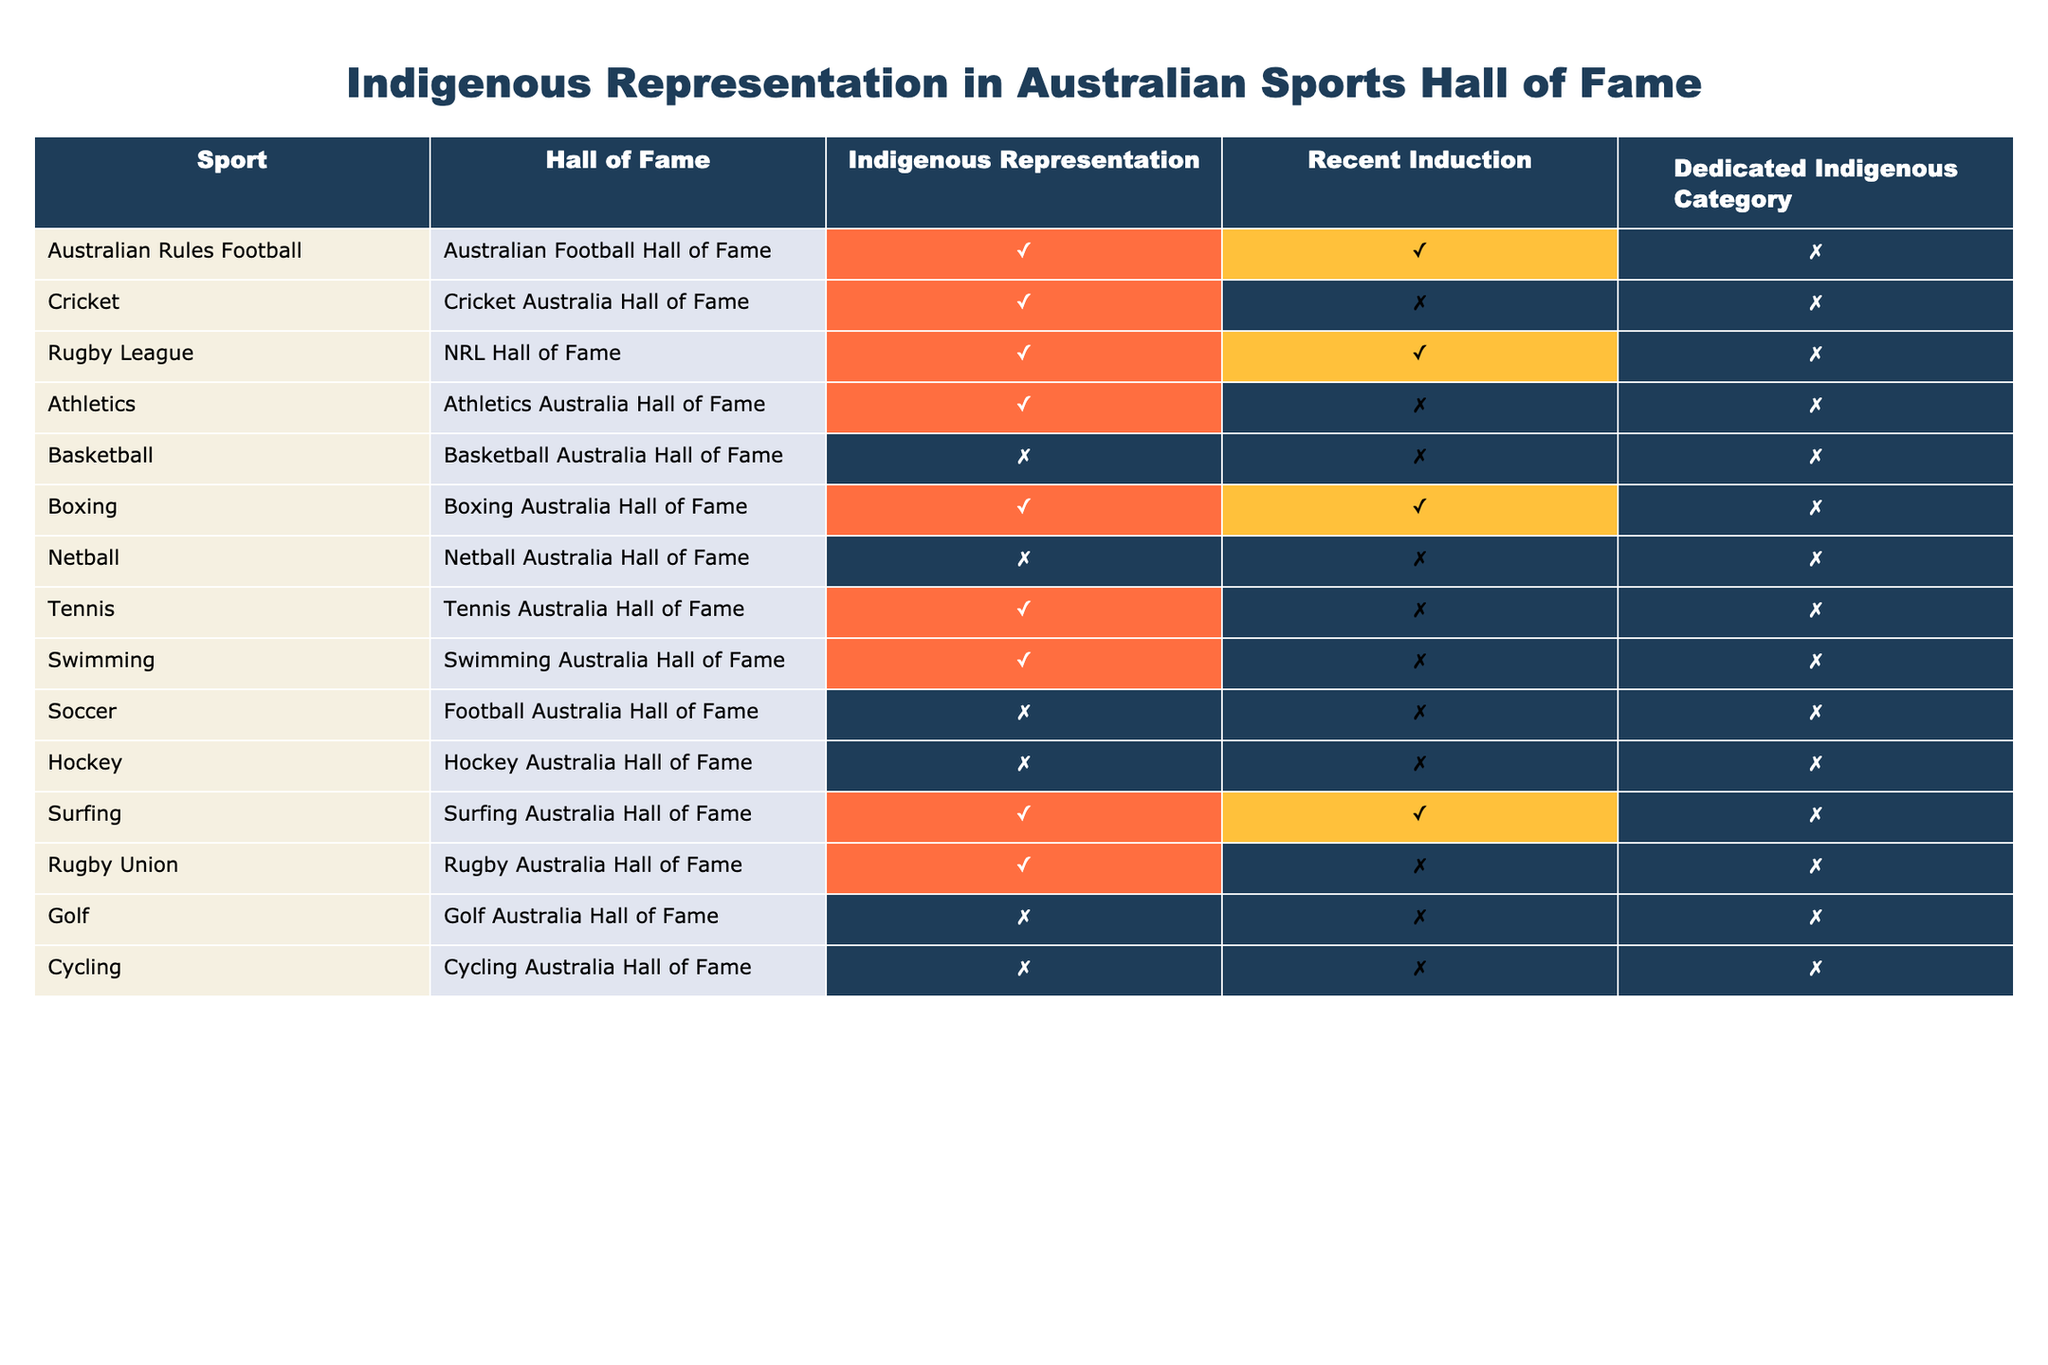What sports have Indigenous representation in their Hall of Fame? From the table, I review the column titled "Indigenous Representation" and identify which sports have a "Yes" marked under that column. These sports are Australian Rules Football, Cricket, Rugby League, Athletics, Boxing, Tennis, Swimming, Surfing, and Rugby Union.
Answer: Australian Rules Football, Cricket, Rugby League, Athletics, Boxing, Tennis, Swimming, Surfing, Rugby Union Which sport has the most recent induction of Indigenous athletes? By examining the "Recent Induction" column, I look for the sports that have a "Yes" under that category. The sports that meet this criterion are Australian Rules Football, Rugby League, and Boxing. I can list these as they all indicate recent induction of Indigenous athletes.
Answer: Australian Rules Football, Rugby League, Boxing Does the Basketball Australia Hall of Fame have Indigenous representation? I check the column for Basketball, and it indicates a "No" under "Indigenous Representation." This means that the Basketball Australia Hall of Fame does not feature Indigenous representation.
Answer: No How many sports have a dedicated Indigenous category? I count the instances in the "Dedicated Indigenous Category" column where it indicates "Yes." Upon reviewing, I find that this category has no "Yes" across all listed sports, indicating that none of them have a dedicated Indigenous category.
Answer: 0 Which sport has Indigenous representation but does not have a recent induction? I analyze the table by looking for sports with a "Yes" in the "Indigenous Representation" column while finding a "No" in the "Recent Induction" column as well. The sports fulfilling this condition are Cricket, Athletics, Tennis, and Swimming.
Answer: Cricket, Athletics, Tennis, Swimming Is there a correlation between Indigenous representation and the existence of a recent induction? To establish a correlation, I evaluate if all sports represented by Indigenous athletes indicate recent induction. Upon inspecting both columns, I see multiple instances of "Yes" for Indigenous representation paired with "Yes" for recent induction, but also instances of "No" for recent induction among those with representation. Hence, there is no definitive correlation.
Answer: No What percentage of the listed sports have Indigenous representation? There are 14 sports listed in total. I find that 9 sports indicate "Yes" for Indigenous representation. To calculate the percentage, I utilize the formula (number of sports with Indigenous representation / total sports) * 100. This results in (9 / 14) * 100 = 64.29%.
Answer: 64.29% Are there any sports with Indigenous representation that also feature a dedicated Indigenous category? I review the table for sports that have both a "Yes" in the "Indigenous Representation" column and a "Yes" in the "Dedicated Indigenous Category" column. Upon checking, there are no sports that meet both conditions; therefore, no sports currently offer a dedicated Indigenous category amidst their representation.
Answer: No 